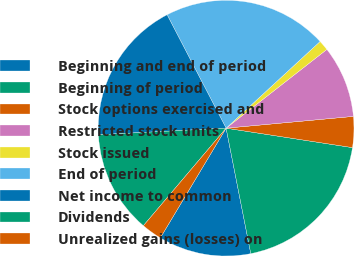Convert chart to OTSL. <chart><loc_0><loc_0><loc_500><loc_500><pie_chart><fcel>Beginning and end of period<fcel>Beginning of period<fcel>Stock options exercised and<fcel>Restricted stock units<fcel>Stock issued<fcel>End of period<fcel>Net income to common<fcel>Dividends<fcel>Unrealized gains (losses) on<nl><fcel>11.69%<fcel>19.48%<fcel>3.9%<fcel>9.09%<fcel>1.3%<fcel>20.78%<fcel>18.18%<fcel>12.99%<fcel>2.6%<nl></chart> 